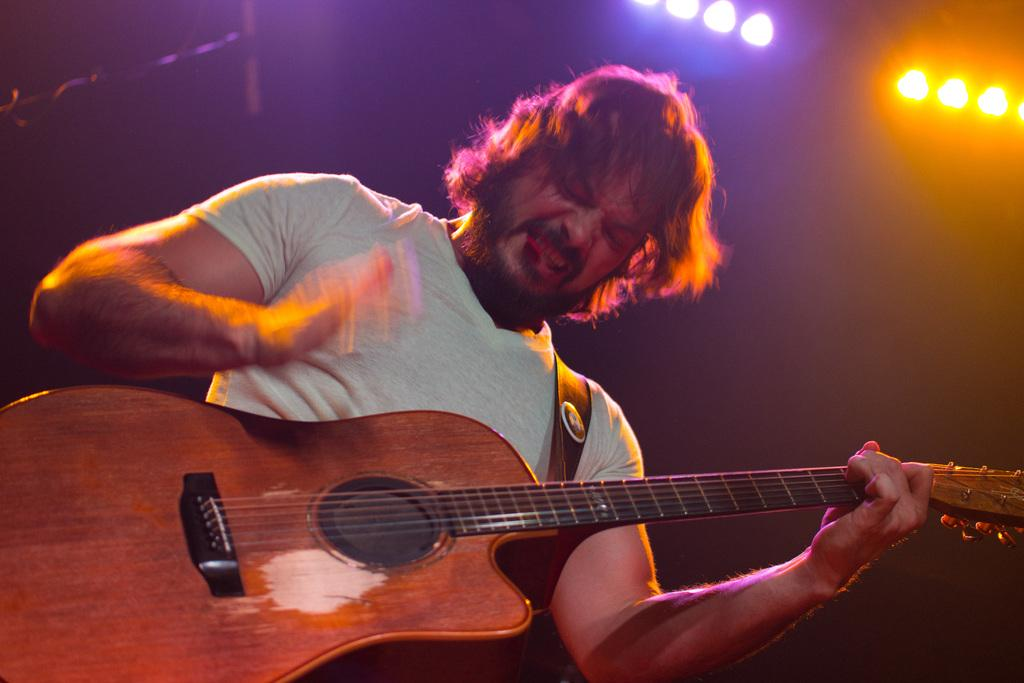What is the main subject of the image? There is a man in the image. What is the man doing in the image? The man is standing and playing a guitar. How many chickens are visible in the image? There are no chickens present in the image. What type of crack is being used to play the guitar in the image? The man is not using any crack to play the guitar; he is using his fingers or a pick. 